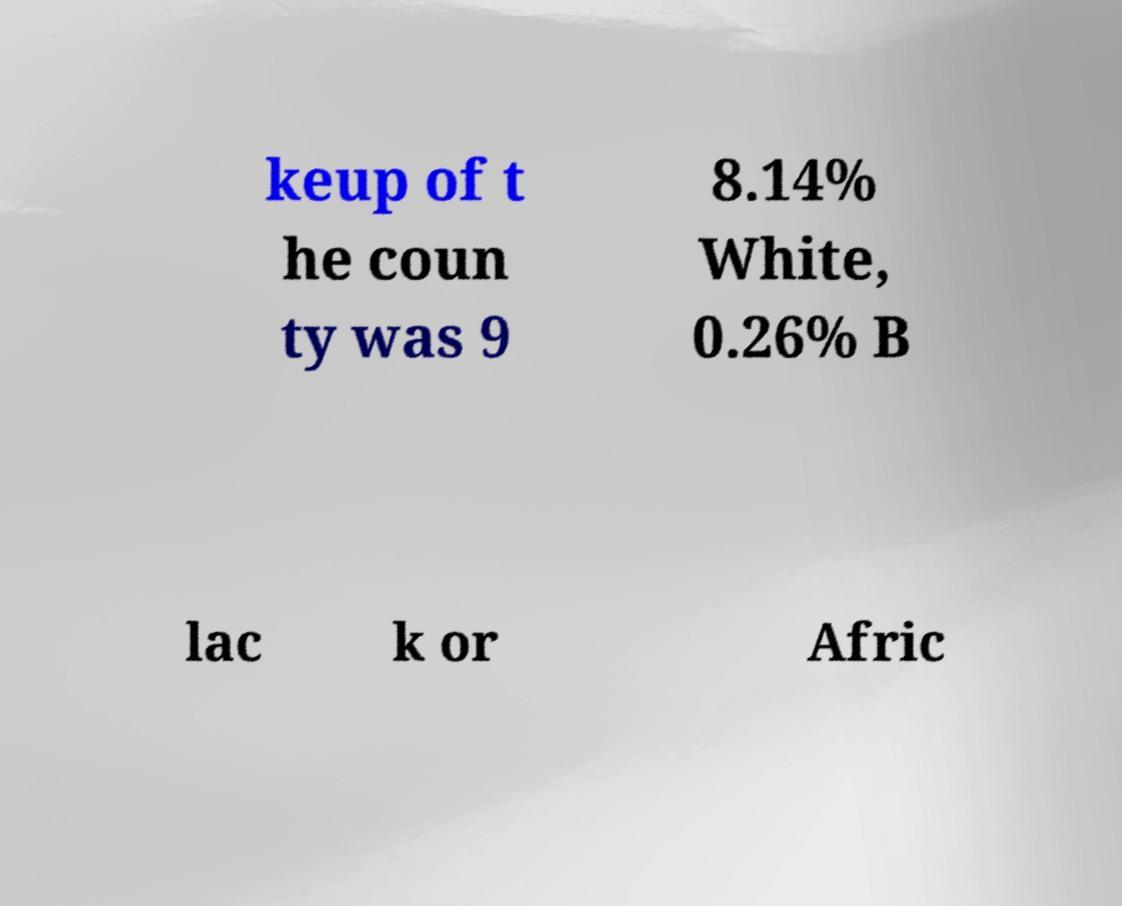Can you read and provide the text displayed in the image?This photo seems to have some interesting text. Can you extract and type it out for me? keup of t he coun ty was 9 8.14% White, 0.26% B lac k or Afric 